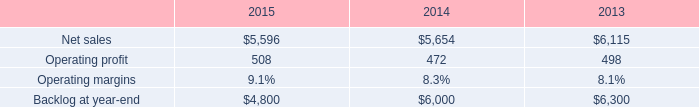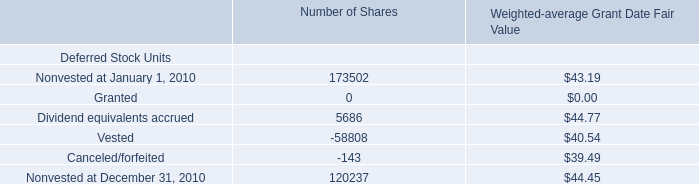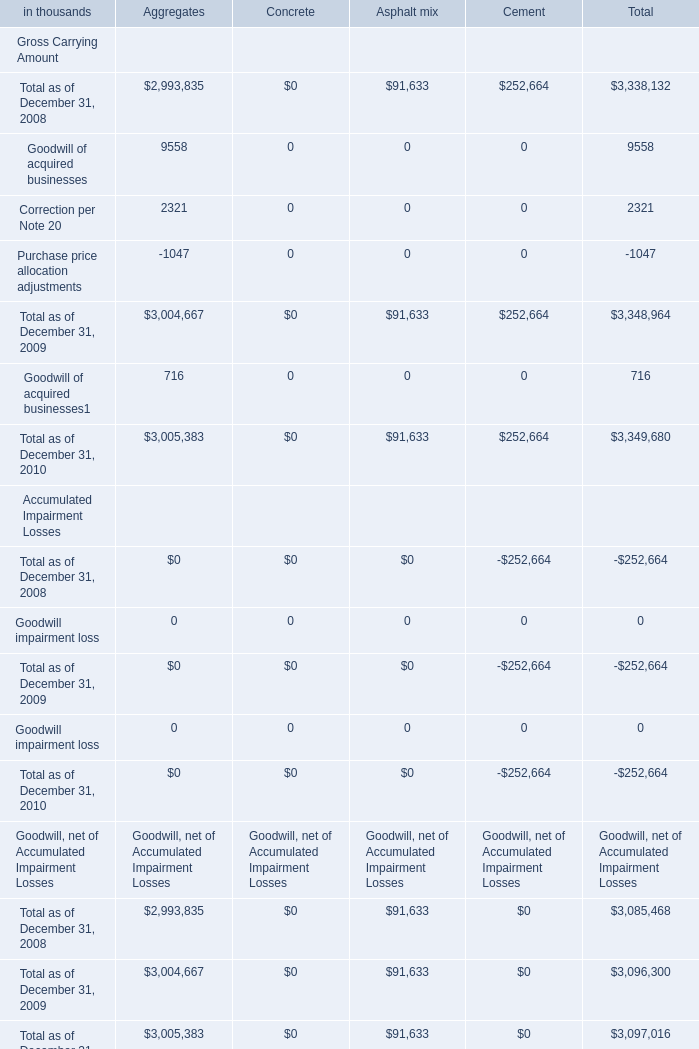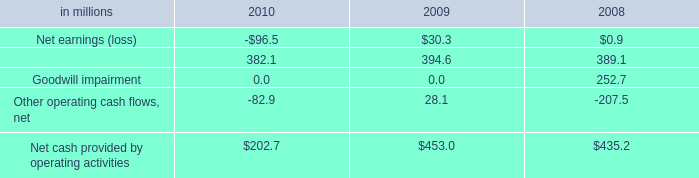what's the total amount of Net sales of 2013, Correction per Note 20 of Aggregates, and Total as of December 31, 2008 Accumulated Impairment Losses of Total ? 
Computations: ((6115.0 + 2321.0) + 252664.0)
Answer: 261100.0. 